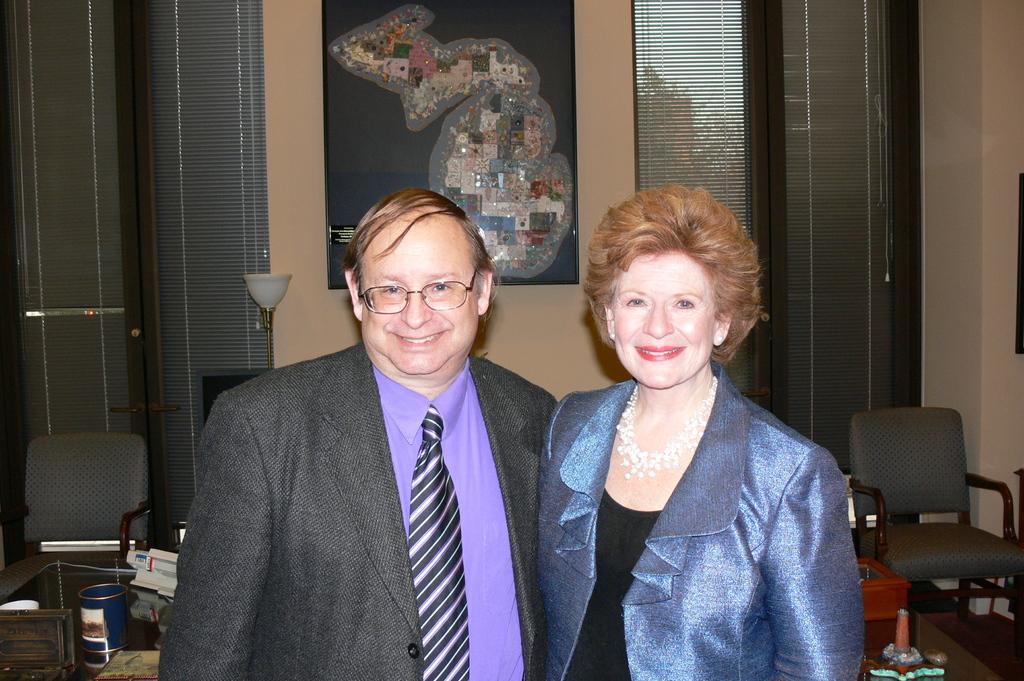How many people are present in the image? There are two people, a man and a woman, present in the image. What expressions do the people in the image have? Both the man and the woman are smiling in the image. What can be seen in the background of the image? There are chairs, a table, and a frame on the wall in the background of the image. What is on the table in the background? There are many things on the table in the background. How many boys are playing with the donkey in the image? There are no boys or donkeys present in the image. 